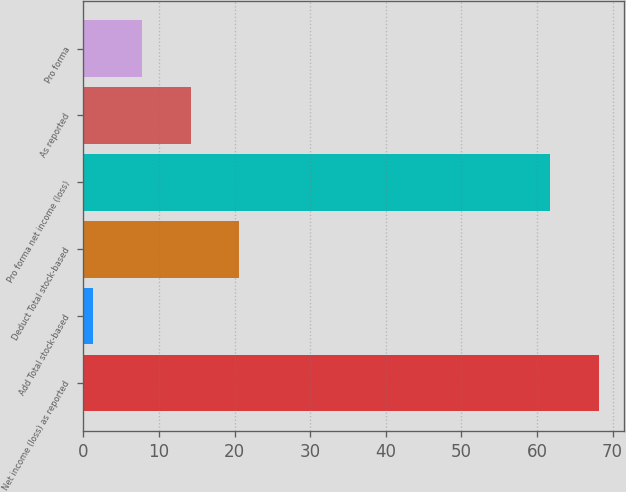Convert chart. <chart><loc_0><loc_0><loc_500><loc_500><bar_chart><fcel>Net income (loss) as reported<fcel>Add Total stock-based<fcel>Deduct Total stock-based<fcel>Pro forma net income (loss)<fcel>As reported<fcel>Pro forma<nl><fcel>68.15<fcel>1.3<fcel>20.65<fcel>61.7<fcel>14.2<fcel>7.75<nl></chart> 